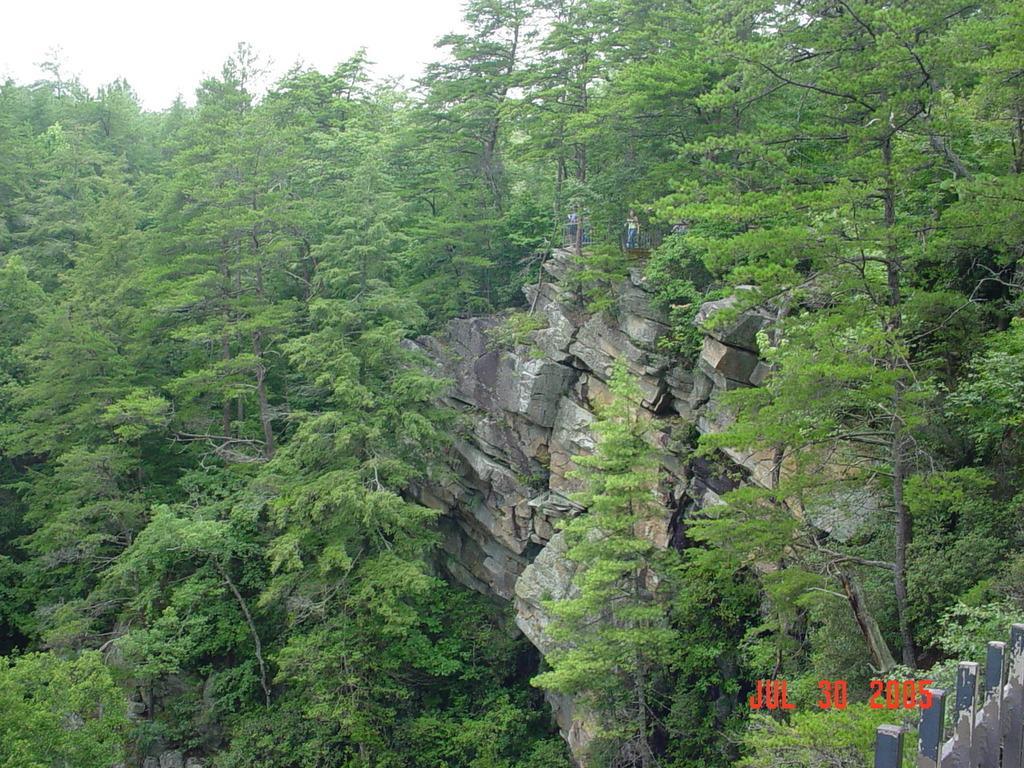Could you give a brief overview of what you see in this image? In this image I can see many trees and rocks. In the background I can see the sky. To the right I can see the fence. 